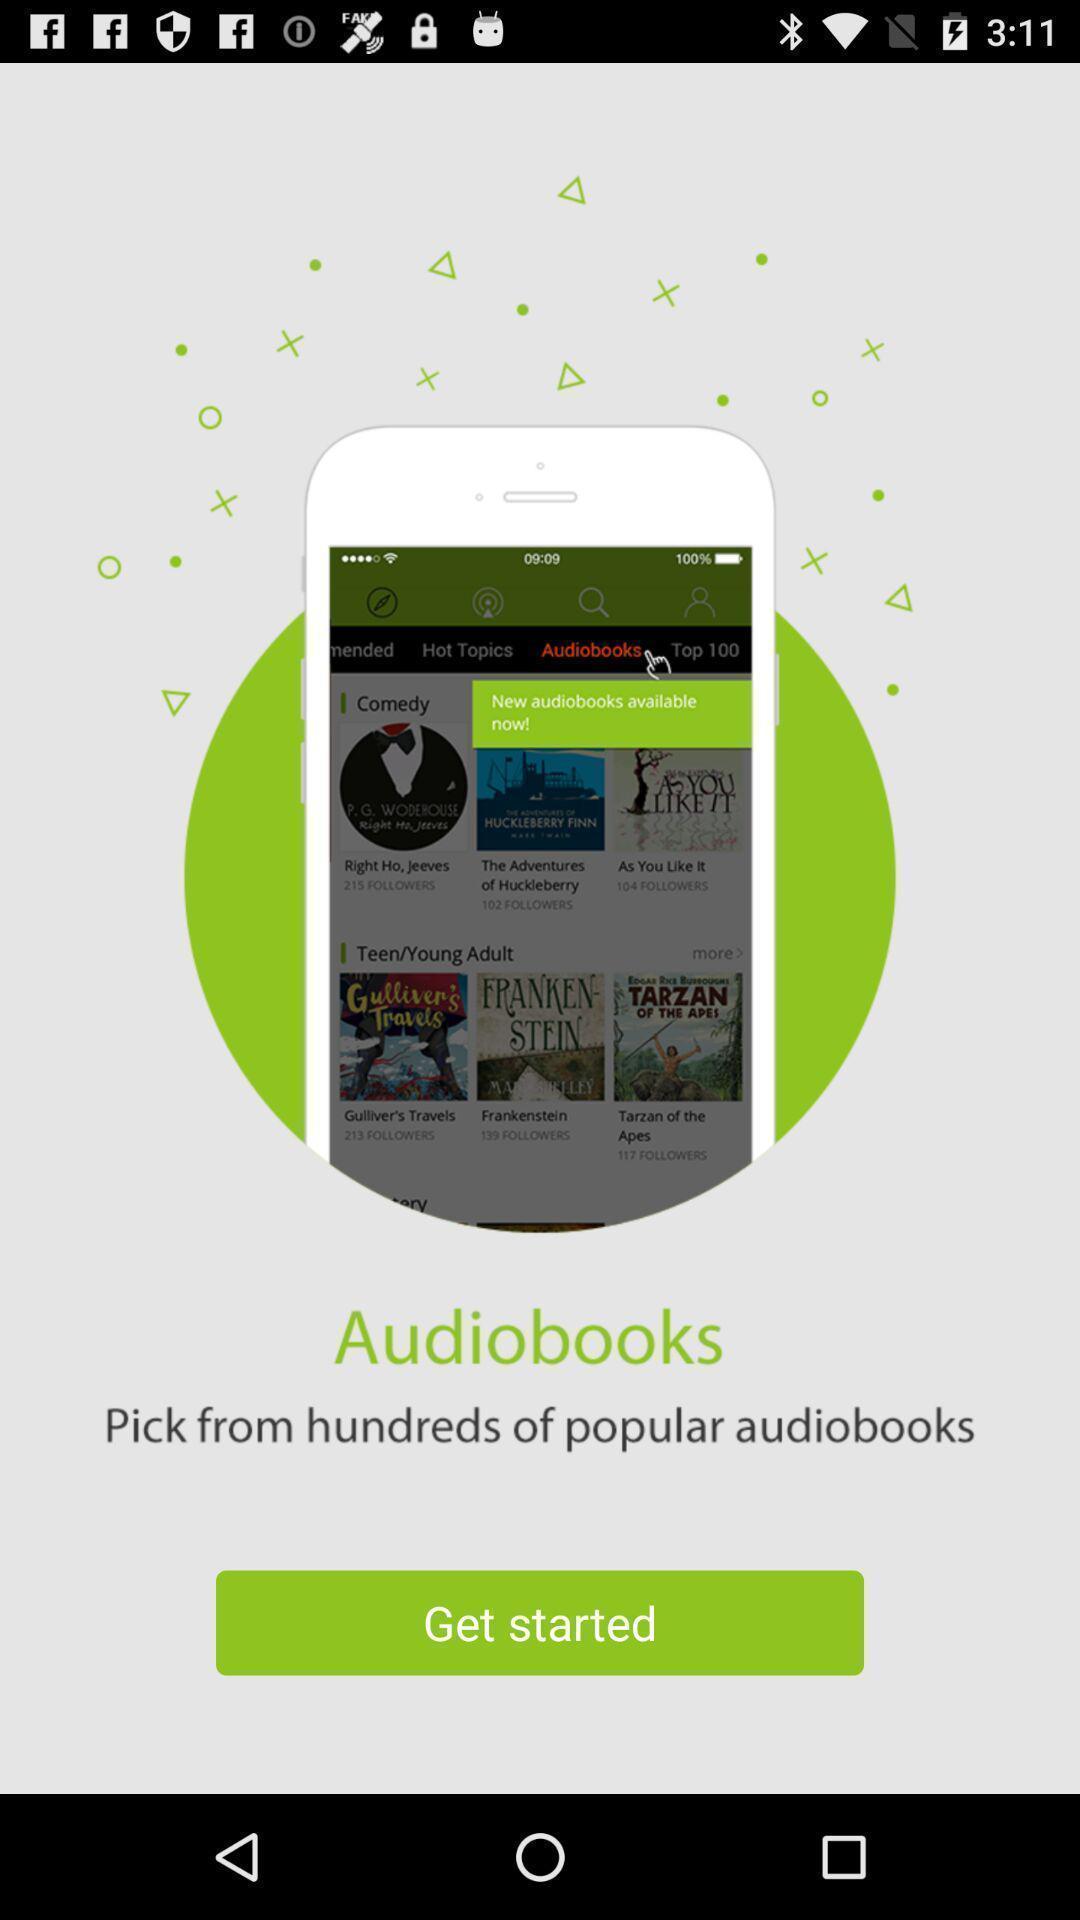Summarize the main components in this picture. Welcome page of a social app. 